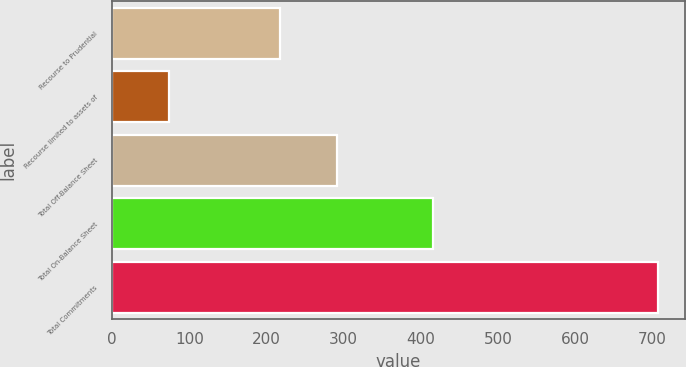Convert chart. <chart><loc_0><loc_0><loc_500><loc_500><bar_chart><fcel>Recourse to Prudential<fcel>Recourse limited to assets of<fcel>Total Off-Balance Sheet<fcel>Total On-Balance Sheet<fcel>Total Commitments<nl><fcel>217<fcel>74<fcel>291<fcel>416<fcel>707<nl></chart> 